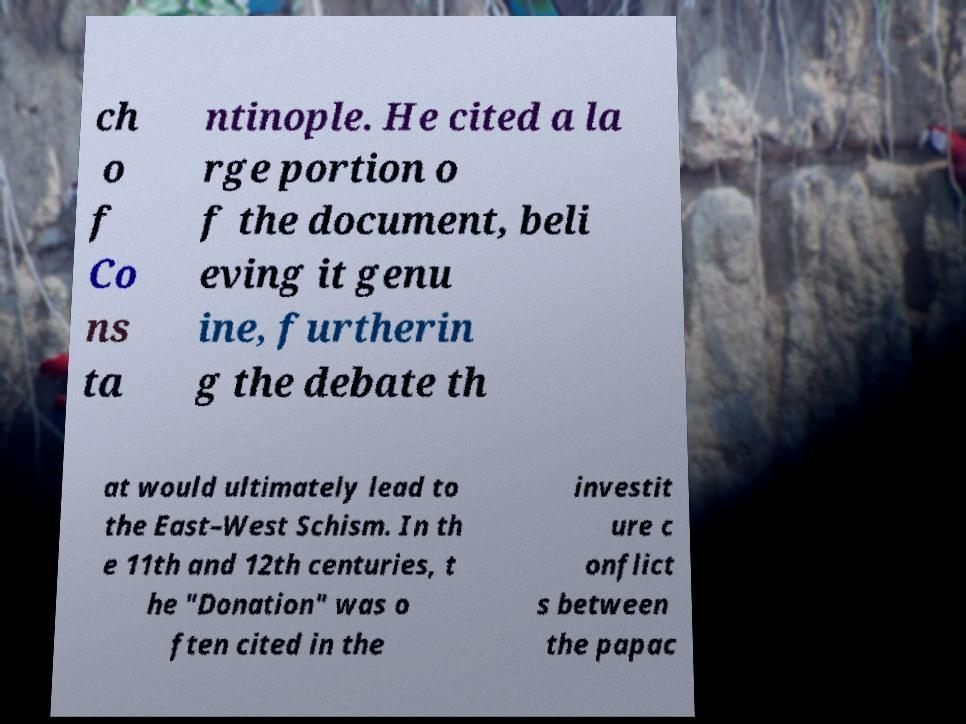Could you assist in decoding the text presented in this image and type it out clearly? ch o f Co ns ta ntinople. He cited a la rge portion o f the document, beli eving it genu ine, furtherin g the debate th at would ultimately lead to the East–West Schism. In th e 11th and 12th centuries, t he "Donation" was o ften cited in the investit ure c onflict s between the papac 